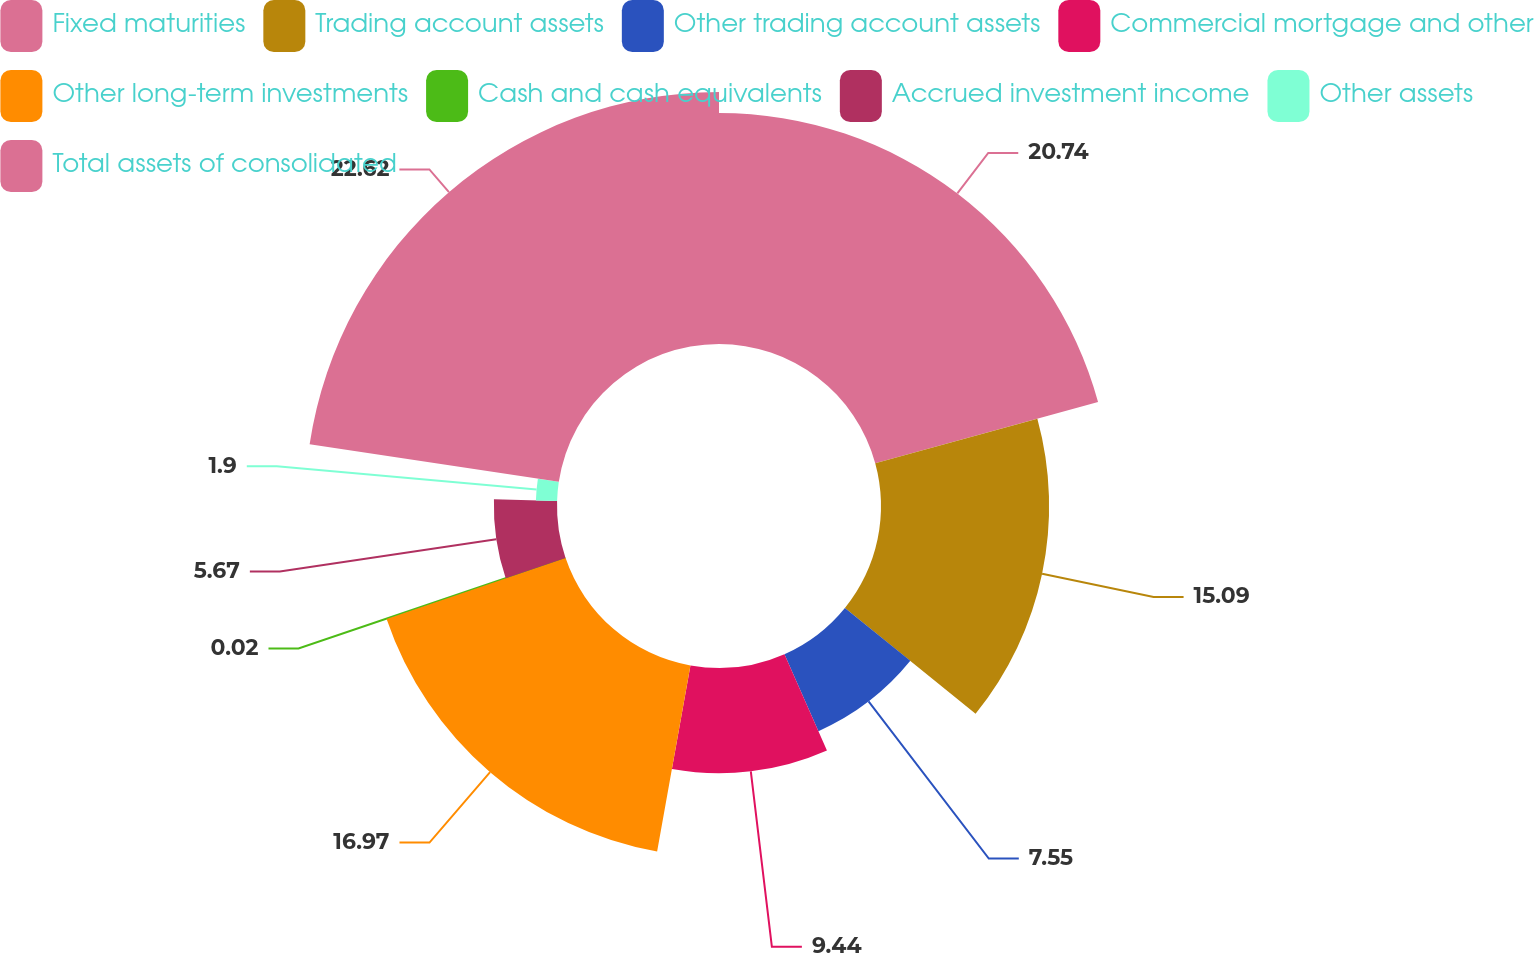Convert chart to OTSL. <chart><loc_0><loc_0><loc_500><loc_500><pie_chart><fcel>Fixed maturities<fcel>Trading account assets<fcel>Other trading account assets<fcel>Commercial mortgage and other<fcel>Other long-term investments<fcel>Cash and cash equivalents<fcel>Accrued investment income<fcel>Other assets<fcel>Total assets of consolidated<nl><fcel>20.74%<fcel>15.09%<fcel>7.55%<fcel>9.44%<fcel>16.97%<fcel>0.02%<fcel>5.67%<fcel>1.9%<fcel>22.62%<nl></chart> 